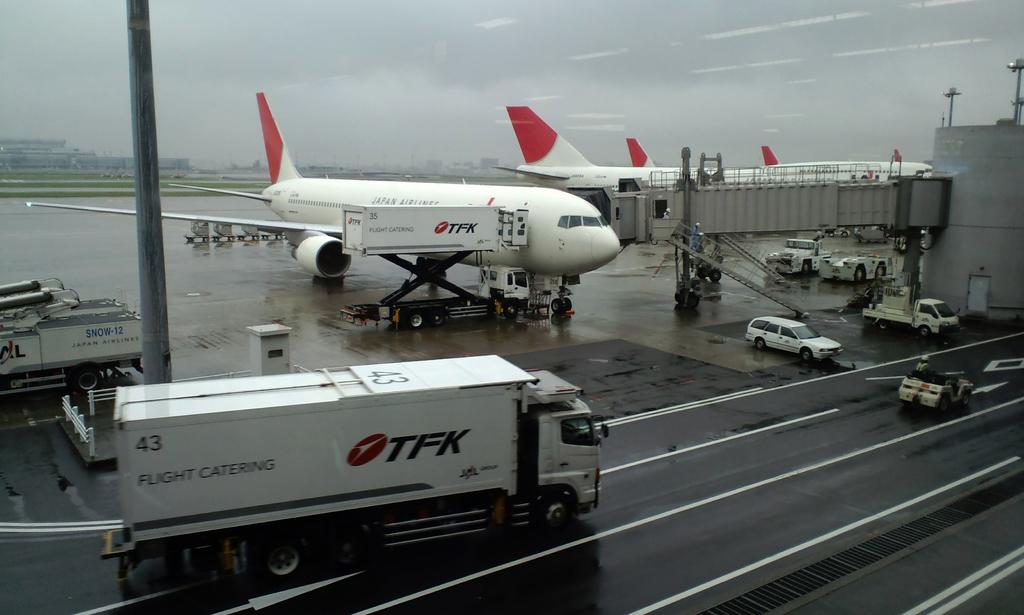Whos airplane is at the gate?
Provide a short and direct response. Tfk. What does tfk do?
Provide a short and direct response. Flight catering. 